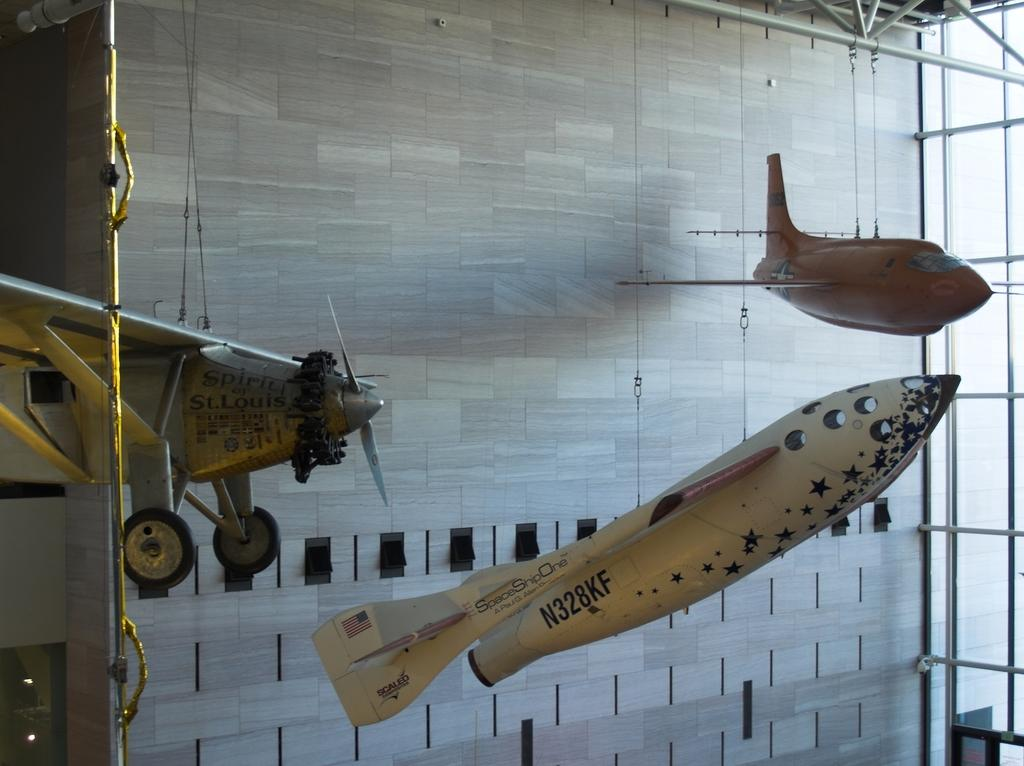What is the main subject in the foreground of the image? There are three aircrafts in the foreground of the image. What can be seen in the background of the image? There is a building wall in the image. What type of material is used for the rods in the image? Metal rods are present in the image. Can you determine the time of day when the image was taken? The image was likely taken during the day, as there is no indication of darkness or artificial lighting. How many cherries are hanging from the twig in the image? There are no cherries or twigs present in the image. 